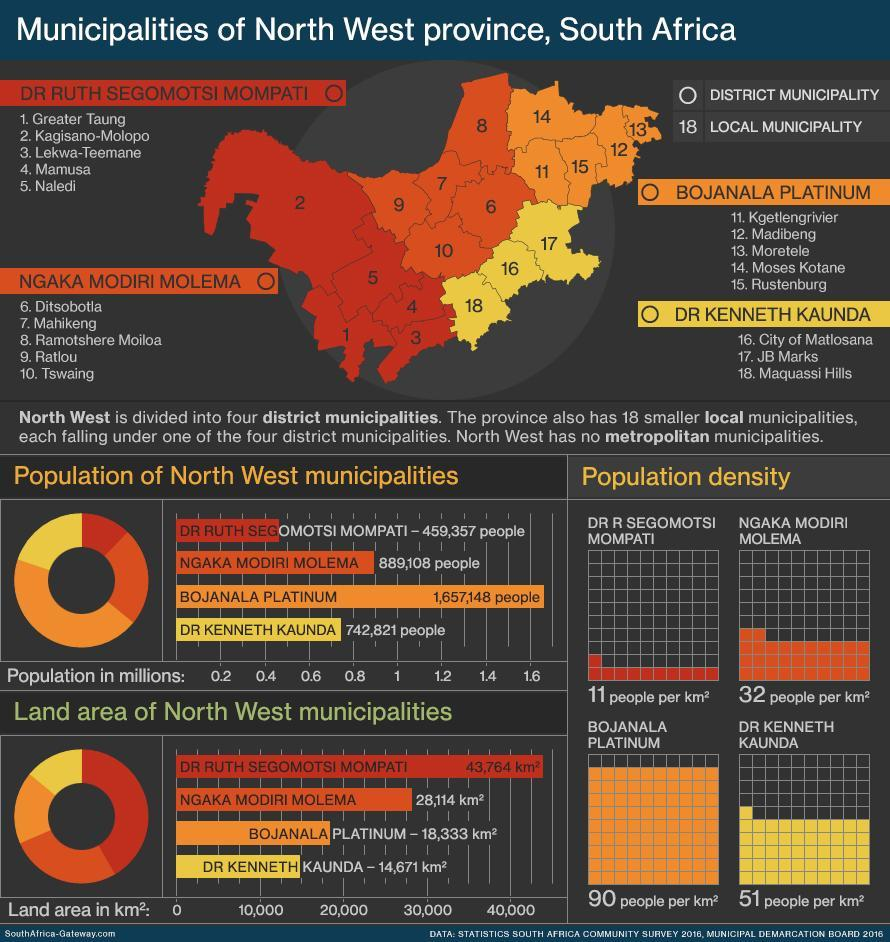Which district municipality is least densely populated?
Answer the question with a short phrase. DR R Segomotsi Mompati Which district municipality is most densely populated? Bojanala Platinum Which district municipality has the highest population? Bojanala Platinum 